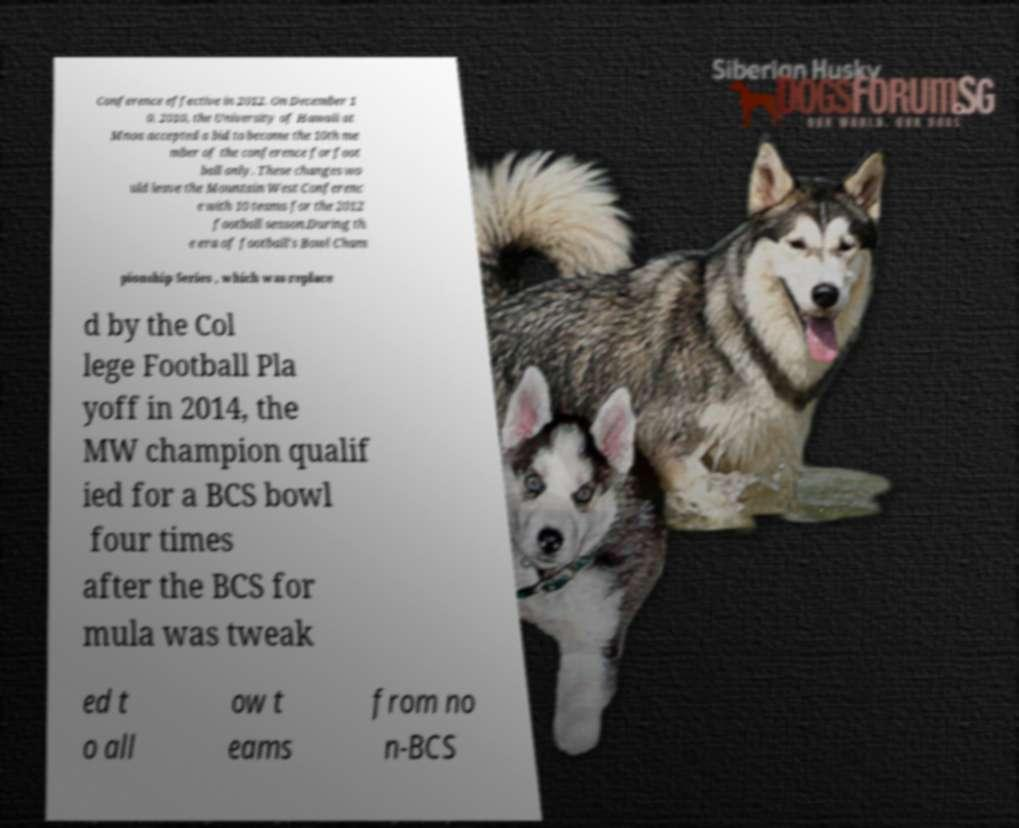Can you accurately transcribe the text from the provided image for me? Conference effective in 2012. On December 1 0, 2010, the University of Hawaii at Mnoa accepted a bid to become the 10th me mber of the conference for foot ball only. These changes wo uld leave the Mountain West Conferenc e with 10 teams for the 2012 football season.During th e era of football's Bowl Cham pionship Series , which was replace d by the Col lege Football Pla yoff in 2014, the MW champion qualif ied for a BCS bowl four times after the BCS for mula was tweak ed t o all ow t eams from no n-BCS 